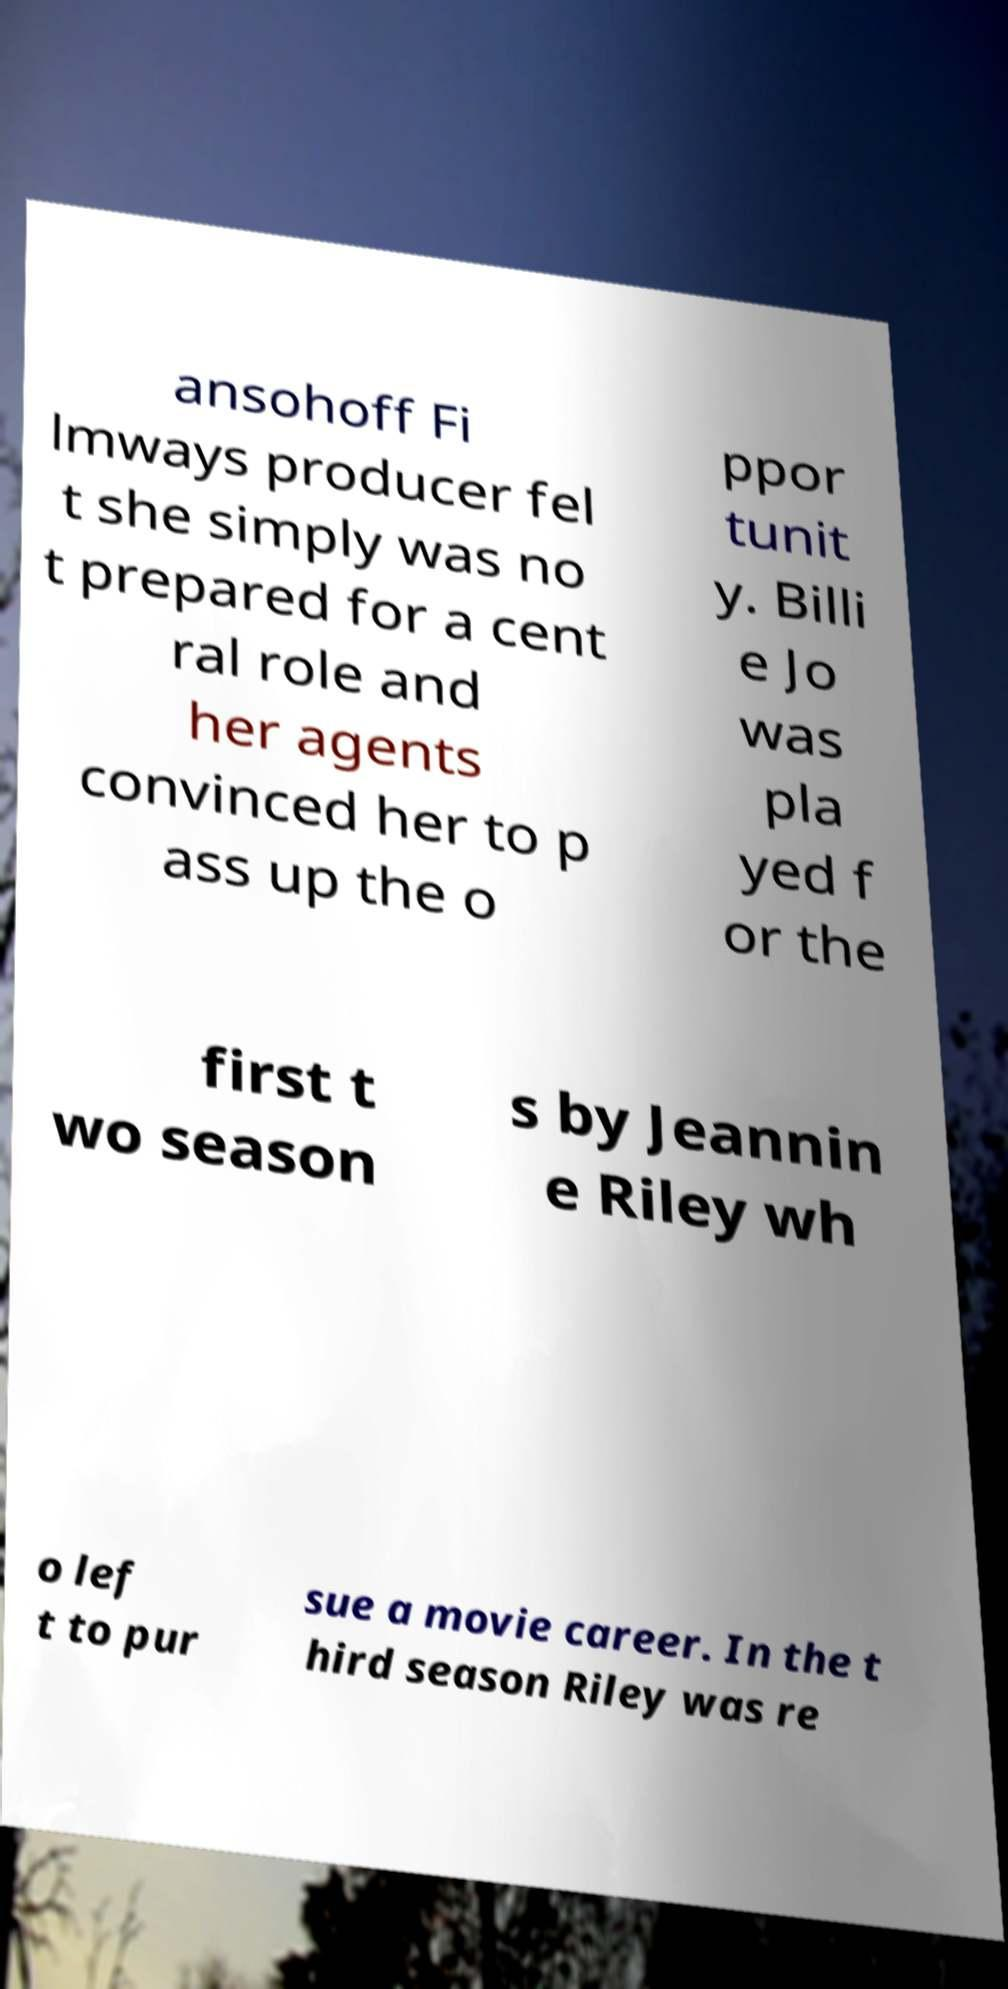Can you read and provide the text displayed in the image?This photo seems to have some interesting text. Can you extract and type it out for me? ansohoff Fi lmways producer fel t she simply was no t prepared for a cent ral role and her agents convinced her to p ass up the o ppor tunit y. Billi e Jo was pla yed f or the first t wo season s by Jeannin e Riley wh o lef t to pur sue a movie career. In the t hird season Riley was re 